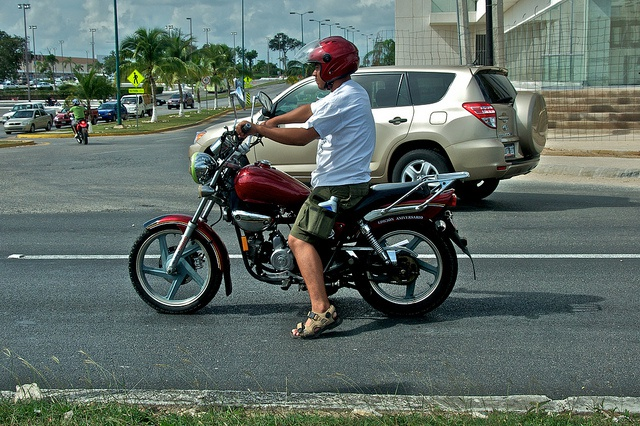Describe the objects in this image and their specific colors. I can see motorcycle in darkgray, black, and gray tones, car in darkgray, gray, black, and white tones, people in darkgray, black, gray, and maroon tones, car in darkgray, black, gray, and blue tones, and car in darkgray, black, blue, navy, and gray tones in this image. 